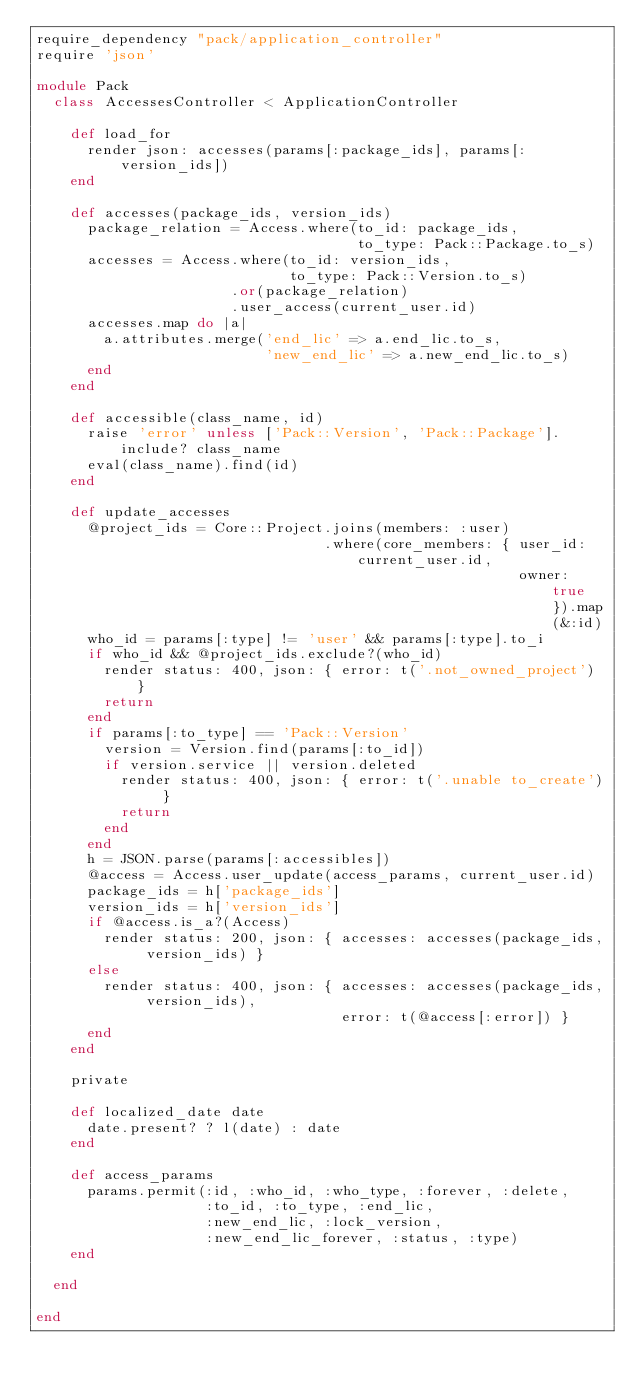<code> <loc_0><loc_0><loc_500><loc_500><_Ruby_>require_dependency "pack/application_controller"
require 'json'

module Pack
  class AccessesController < ApplicationController

    def load_for
      render json: accesses(params[:package_ids], params[:version_ids])
    end

    def accesses(package_ids, version_ids)
      package_relation = Access.where(to_id: package_ids,
                                      to_type: Pack::Package.to_s)
      accesses = Access.where(to_id: version_ids,
                              to_type: Pack::Version.to_s)
                       .or(package_relation)
                       .user_access(current_user.id)
      accesses.map do |a|
        a.attributes.merge('end_lic' => a.end_lic.to_s,
                           'new_end_lic' => a.new_end_lic.to_s)
      end
    end

    def accessible(class_name, id)
      raise 'error' unless ['Pack::Version', 'Pack::Package'].include? class_name
      eval(class_name).find(id)
    end

    def update_accesses
      @project_ids = Core::Project.joins(members: :user)
                                  .where(core_members: { user_id: current_user.id,
                                                         owner: true }).map(&:id)
      who_id = params[:type] != 'user' && params[:type].to_i
      if who_id && @project_ids.exclude?(who_id)
        render status: 400, json: { error: t('.not_owned_project') }
        return
      end
      if params[:to_type] == 'Pack::Version'
        version = Version.find(params[:to_id])
        if version.service || version.deleted
          render status: 400, json: { error: t('.unable to_create') }
          return
        end
      end
      h = JSON.parse(params[:accessibles])
      @access = Access.user_update(access_params, current_user.id)
      package_ids = h['package_ids']
      version_ids = h['version_ids']
      if @access.is_a?(Access)
        render status: 200, json: { accesses: accesses(package_ids, version_ids) }
      else
        render status: 400, json: { accesses: accesses(package_ids, version_ids),
                                    error: t(@access[:error]) }
      end
    end

    private

    def localized_date date
      date.present? ? l(date) : date
    end

  	def access_params
      params.permit(:id, :who_id, :who_type, :forever, :delete,
                    :to_id, :to_type, :end_lic,
                    :new_end_lic, :lock_version,
                    :new_end_lic_forever, :status, :type)
    end

  end

end
</code> 